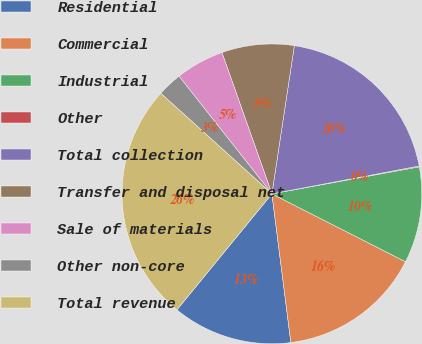<chart> <loc_0><loc_0><loc_500><loc_500><pie_chart><fcel>Residential<fcel>Commercial<fcel>Industrial<fcel>Other<fcel>Total collection<fcel>Transfer and disposal net<fcel>Sale of materials<fcel>Other non-core<fcel>Total revenue<nl><fcel>12.94%<fcel>15.5%<fcel>10.37%<fcel>0.09%<fcel>19.63%<fcel>7.8%<fcel>5.23%<fcel>2.66%<fcel>25.78%<nl></chart> 